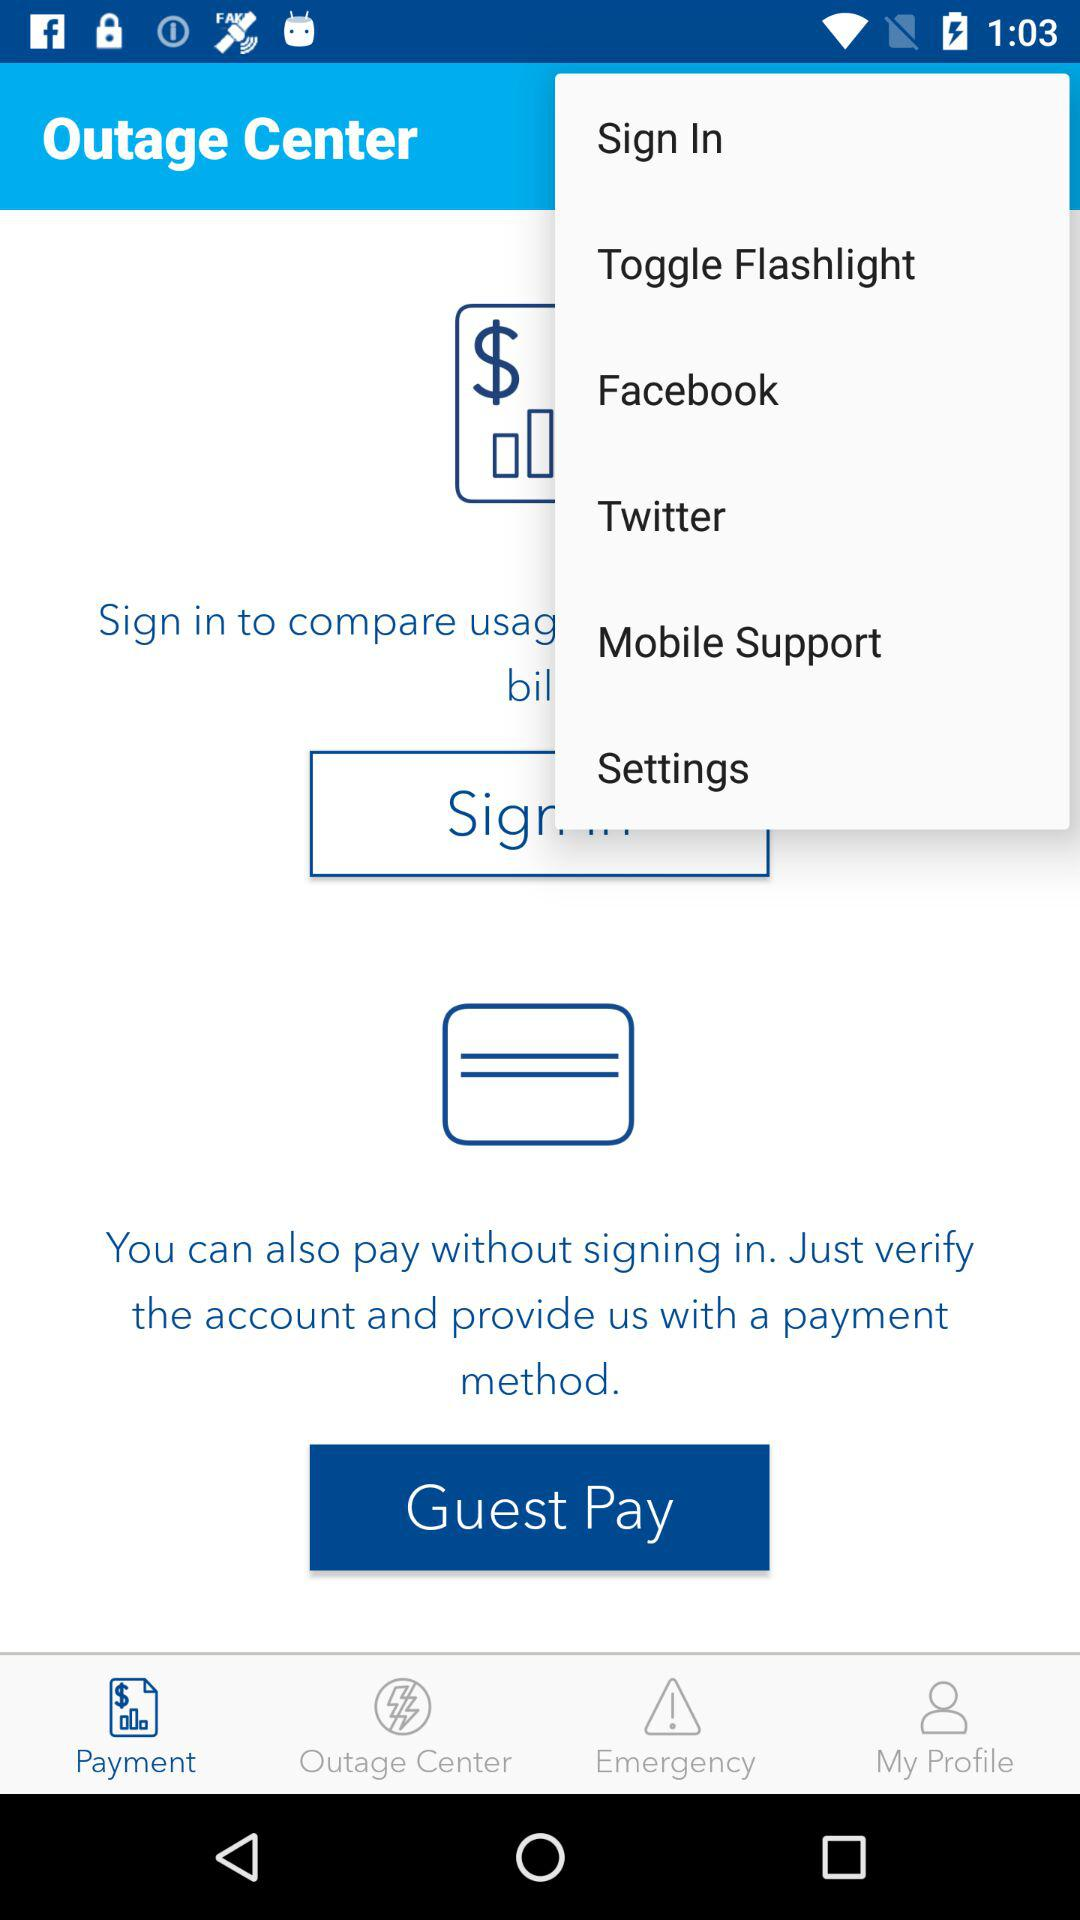Which tab at the bottom of the page is now active? The active tab is "Payment". 